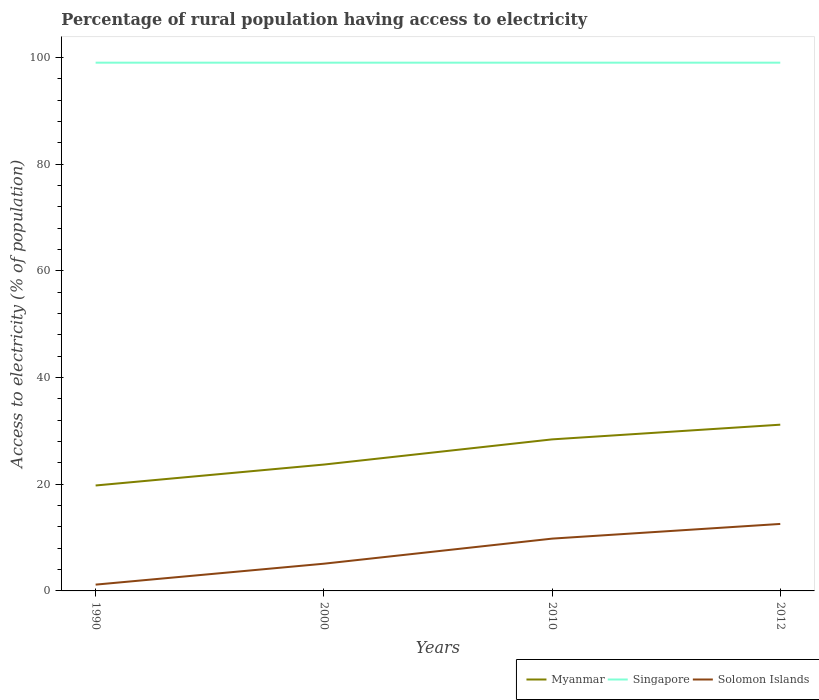Does the line corresponding to Solomon Islands intersect with the line corresponding to Singapore?
Offer a very short reply. No. Is the number of lines equal to the number of legend labels?
Provide a succinct answer. Yes. Across all years, what is the maximum percentage of rural population having access to electricity in Singapore?
Ensure brevity in your answer.  99. What is the total percentage of rural population having access to electricity in Myanmar in the graph?
Offer a very short reply. -8.64. What is the difference between the highest and the second highest percentage of rural population having access to electricity in Myanmar?
Provide a succinct answer. 11.39. What is the difference between the highest and the lowest percentage of rural population having access to electricity in Solomon Islands?
Provide a short and direct response. 2. Is the percentage of rural population having access to electricity in Solomon Islands strictly greater than the percentage of rural population having access to electricity in Singapore over the years?
Your response must be concise. Yes. How many lines are there?
Offer a terse response. 3. Does the graph contain any zero values?
Your answer should be very brief. No. Does the graph contain grids?
Offer a very short reply. No. How many legend labels are there?
Offer a terse response. 3. How are the legend labels stacked?
Provide a short and direct response. Horizontal. What is the title of the graph?
Offer a very short reply. Percentage of rural population having access to electricity. Does "Heavily indebted poor countries" appear as one of the legend labels in the graph?
Provide a short and direct response. No. What is the label or title of the X-axis?
Keep it short and to the point. Years. What is the label or title of the Y-axis?
Ensure brevity in your answer.  Access to electricity (% of population). What is the Access to electricity (% of population) in Myanmar in 1990?
Your response must be concise. 19.76. What is the Access to electricity (% of population) in Singapore in 1990?
Offer a very short reply. 99. What is the Access to electricity (% of population) of Solomon Islands in 1990?
Offer a very short reply. 1.18. What is the Access to electricity (% of population) in Myanmar in 2000?
Offer a terse response. 23.68. What is the Access to electricity (% of population) of Singapore in 2000?
Your response must be concise. 99. What is the Access to electricity (% of population) in Myanmar in 2010?
Make the answer very short. 28.4. What is the Access to electricity (% of population) in Myanmar in 2012?
Ensure brevity in your answer.  31.15. What is the Access to electricity (% of population) of Solomon Islands in 2012?
Offer a terse response. 12.55. Across all years, what is the maximum Access to electricity (% of population) of Myanmar?
Keep it short and to the point. 31.15. Across all years, what is the maximum Access to electricity (% of population) of Singapore?
Your answer should be very brief. 99. Across all years, what is the maximum Access to electricity (% of population) in Solomon Islands?
Provide a succinct answer. 12.55. Across all years, what is the minimum Access to electricity (% of population) in Myanmar?
Ensure brevity in your answer.  19.76. Across all years, what is the minimum Access to electricity (% of population) of Singapore?
Your response must be concise. 99. Across all years, what is the minimum Access to electricity (% of population) of Solomon Islands?
Ensure brevity in your answer.  1.18. What is the total Access to electricity (% of population) of Myanmar in the graph?
Offer a very short reply. 103. What is the total Access to electricity (% of population) in Singapore in the graph?
Your response must be concise. 396. What is the total Access to electricity (% of population) in Solomon Islands in the graph?
Offer a terse response. 28.63. What is the difference between the Access to electricity (% of population) in Myanmar in 1990 and that in 2000?
Give a very brief answer. -3.92. What is the difference between the Access to electricity (% of population) in Singapore in 1990 and that in 2000?
Offer a terse response. 0. What is the difference between the Access to electricity (% of population) in Solomon Islands in 1990 and that in 2000?
Your answer should be very brief. -3.92. What is the difference between the Access to electricity (% of population) in Myanmar in 1990 and that in 2010?
Provide a short and direct response. -8.64. What is the difference between the Access to electricity (% of population) of Solomon Islands in 1990 and that in 2010?
Offer a very short reply. -8.62. What is the difference between the Access to electricity (% of population) of Myanmar in 1990 and that in 2012?
Your response must be concise. -11.39. What is the difference between the Access to electricity (% of population) of Solomon Islands in 1990 and that in 2012?
Ensure brevity in your answer.  -11.38. What is the difference between the Access to electricity (% of population) of Myanmar in 2000 and that in 2010?
Keep it short and to the point. -4.72. What is the difference between the Access to electricity (% of population) in Solomon Islands in 2000 and that in 2010?
Ensure brevity in your answer.  -4.7. What is the difference between the Access to electricity (% of population) of Myanmar in 2000 and that in 2012?
Provide a short and direct response. -7.47. What is the difference between the Access to electricity (% of population) in Solomon Islands in 2000 and that in 2012?
Provide a short and direct response. -7.45. What is the difference between the Access to electricity (% of population) of Myanmar in 2010 and that in 2012?
Provide a short and direct response. -2.75. What is the difference between the Access to electricity (% of population) in Singapore in 2010 and that in 2012?
Offer a very short reply. 0. What is the difference between the Access to electricity (% of population) in Solomon Islands in 2010 and that in 2012?
Make the answer very short. -2.75. What is the difference between the Access to electricity (% of population) of Myanmar in 1990 and the Access to electricity (% of population) of Singapore in 2000?
Your answer should be compact. -79.24. What is the difference between the Access to electricity (% of population) of Myanmar in 1990 and the Access to electricity (% of population) of Solomon Islands in 2000?
Make the answer very short. 14.66. What is the difference between the Access to electricity (% of population) in Singapore in 1990 and the Access to electricity (% of population) in Solomon Islands in 2000?
Provide a short and direct response. 93.9. What is the difference between the Access to electricity (% of population) of Myanmar in 1990 and the Access to electricity (% of population) of Singapore in 2010?
Provide a short and direct response. -79.24. What is the difference between the Access to electricity (% of population) of Myanmar in 1990 and the Access to electricity (% of population) of Solomon Islands in 2010?
Make the answer very short. 9.96. What is the difference between the Access to electricity (% of population) of Singapore in 1990 and the Access to electricity (% of population) of Solomon Islands in 2010?
Offer a terse response. 89.2. What is the difference between the Access to electricity (% of population) of Myanmar in 1990 and the Access to electricity (% of population) of Singapore in 2012?
Give a very brief answer. -79.24. What is the difference between the Access to electricity (% of population) in Myanmar in 1990 and the Access to electricity (% of population) in Solomon Islands in 2012?
Your answer should be very brief. 7.21. What is the difference between the Access to electricity (% of population) of Singapore in 1990 and the Access to electricity (% of population) of Solomon Islands in 2012?
Offer a terse response. 86.45. What is the difference between the Access to electricity (% of population) in Myanmar in 2000 and the Access to electricity (% of population) in Singapore in 2010?
Offer a very short reply. -75.32. What is the difference between the Access to electricity (% of population) of Myanmar in 2000 and the Access to electricity (% of population) of Solomon Islands in 2010?
Provide a short and direct response. 13.88. What is the difference between the Access to electricity (% of population) in Singapore in 2000 and the Access to electricity (% of population) in Solomon Islands in 2010?
Offer a very short reply. 89.2. What is the difference between the Access to electricity (% of population) in Myanmar in 2000 and the Access to electricity (% of population) in Singapore in 2012?
Ensure brevity in your answer.  -75.32. What is the difference between the Access to electricity (% of population) of Myanmar in 2000 and the Access to electricity (% of population) of Solomon Islands in 2012?
Keep it short and to the point. 11.13. What is the difference between the Access to electricity (% of population) in Singapore in 2000 and the Access to electricity (% of population) in Solomon Islands in 2012?
Offer a very short reply. 86.45. What is the difference between the Access to electricity (% of population) of Myanmar in 2010 and the Access to electricity (% of population) of Singapore in 2012?
Offer a terse response. -70.6. What is the difference between the Access to electricity (% of population) of Myanmar in 2010 and the Access to electricity (% of population) of Solomon Islands in 2012?
Provide a short and direct response. 15.85. What is the difference between the Access to electricity (% of population) in Singapore in 2010 and the Access to electricity (% of population) in Solomon Islands in 2012?
Make the answer very short. 86.45. What is the average Access to electricity (% of population) of Myanmar per year?
Your response must be concise. 25.75. What is the average Access to electricity (% of population) in Solomon Islands per year?
Offer a terse response. 7.16. In the year 1990, what is the difference between the Access to electricity (% of population) in Myanmar and Access to electricity (% of population) in Singapore?
Provide a short and direct response. -79.24. In the year 1990, what is the difference between the Access to electricity (% of population) in Myanmar and Access to electricity (% of population) in Solomon Islands?
Give a very brief answer. 18.58. In the year 1990, what is the difference between the Access to electricity (% of population) of Singapore and Access to electricity (% of population) of Solomon Islands?
Your answer should be compact. 97.82. In the year 2000, what is the difference between the Access to electricity (% of population) in Myanmar and Access to electricity (% of population) in Singapore?
Your answer should be compact. -75.32. In the year 2000, what is the difference between the Access to electricity (% of population) of Myanmar and Access to electricity (% of population) of Solomon Islands?
Ensure brevity in your answer.  18.58. In the year 2000, what is the difference between the Access to electricity (% of population) of Singapore and Access to electricity (% of population) of Solomon Islands?
Your response must be concise. 93.9. In the year 2010, what is the difference between the Access to electricity (% of population) of Myanmar and Access to electricity (% of population) of Singapore?
Give a very brief answer. -70.6. In the year 2010, what is the difference between the Access to electricity (% of population) of Myanmar and Access to electricity (% of population) of Solomon Islands?
Give a very brief answer. 18.6. In the year 2010, what is the difference between the Access to electricity (% of population) of Singapore and Access to electricity (% of population) of Solomon Islands?
Offer a terse response. 89.2. In the year 2012, what is the difference between the Access to electricity (% of population) in Myanmar and Access to electricity (% of population) in Singapore?
Make the answer very short. -67.85. In the year 2012, what is the difference between the Access to electricity (% of population) in Singapore and Access to electricity (% of population) in Solomon Islands?
Make the answer very short. 86.45. What is the ratio of the Access to electricity (% of population) of Myanmar in 1990 to that in 2000?
Ensure brevity in your answer.  0.83. What is the ratio of the Access to electricity (% of population) of Singapore in 1990 to that in 2000?
Provide a succinct answer. 1. What is the ratio of the Access to electricity (% of population) in Solomon Islands in 1990 to that in 2000?
Provide a succinct answer. 0.23. What is the ratio of the Access to electricity (% of population) of Myanmar in 1990 to that in 2010?
Keep it short and to the point. 0.7. What is the ratio of the Access to electricity (% of population) in Solomon Islands in 1990 to that in 2010?
Ensure brevity in your answer.  0.12. What is the ratio of the Access to electricity (% of population) in Myanmar in 1990 to that in 2012?
Your response must be concise. 0.63. What is the ratio of the Access to electricity (% of population) in Singapore in 1990 to that in 2012?
Give a very brief answer. 1. What is the ratio of the Access to electricity (% of population) in Solomon Islands in 1990 to that in 2012?
Make the answer very short. 0.09. What is the ratio of the Access to electricity (% of population) of Myanmar in 2000 to that in 2010?
Ensure brevity in your answer.  0.83. What is the ratio of the Access to electricity (% of population) in Singapore in 2000 to that in 2010?
Offer a terse response. 1. What is the ratio of the Access to electricity (% of population) of Solomon Islands in 2000 to that in 2010?
Provide a short and direct response. 0.52. What is the ratio of the Access to electricity (% of population) in Myanmar in 2000 to that in 2012?
Provide a succinct answer. 0.76. What is the ratio of the Access to electricity (% of population) in Singapore in 2000 to that in 2012?
Your response must be concise. 1. What is the ratio of the Access to electricity (% of population) of Solomon Islands in 2000 to that in 2012?
Offer a terse response. 0.41. What is the ratio of the Access to electricity (% of population) in Myanmar in 2010 to that in 2012?
Your response must be concise. 0.91. What is the ratio of the Access to electricity (% of population) of Solomon Islands in 2010 to that in 2012?
Your answer should be very brief. 0.78. What is the difference between the highest and the second highest Access to electricity (% of population) of Myanmar?
Your response must be concise. 2.75. What is the difference between the highest and the second highest Access to electricity (% of population) in Solomon Islands?
Provide a succinct answer. 2.75. What is the difference between the highest and the lowest Access to electricity (% of population) of Myanmar?
Make the answer very short. 11.39. What is the difference between the highest and the lowest Access to electricity (% of population) in Singapore?
Offer a terse response. 0. What is the difference between the highest and the lowest Access to electricity (% of population) in Solomon Islands?
Provide a succinct answer. 11.38. 